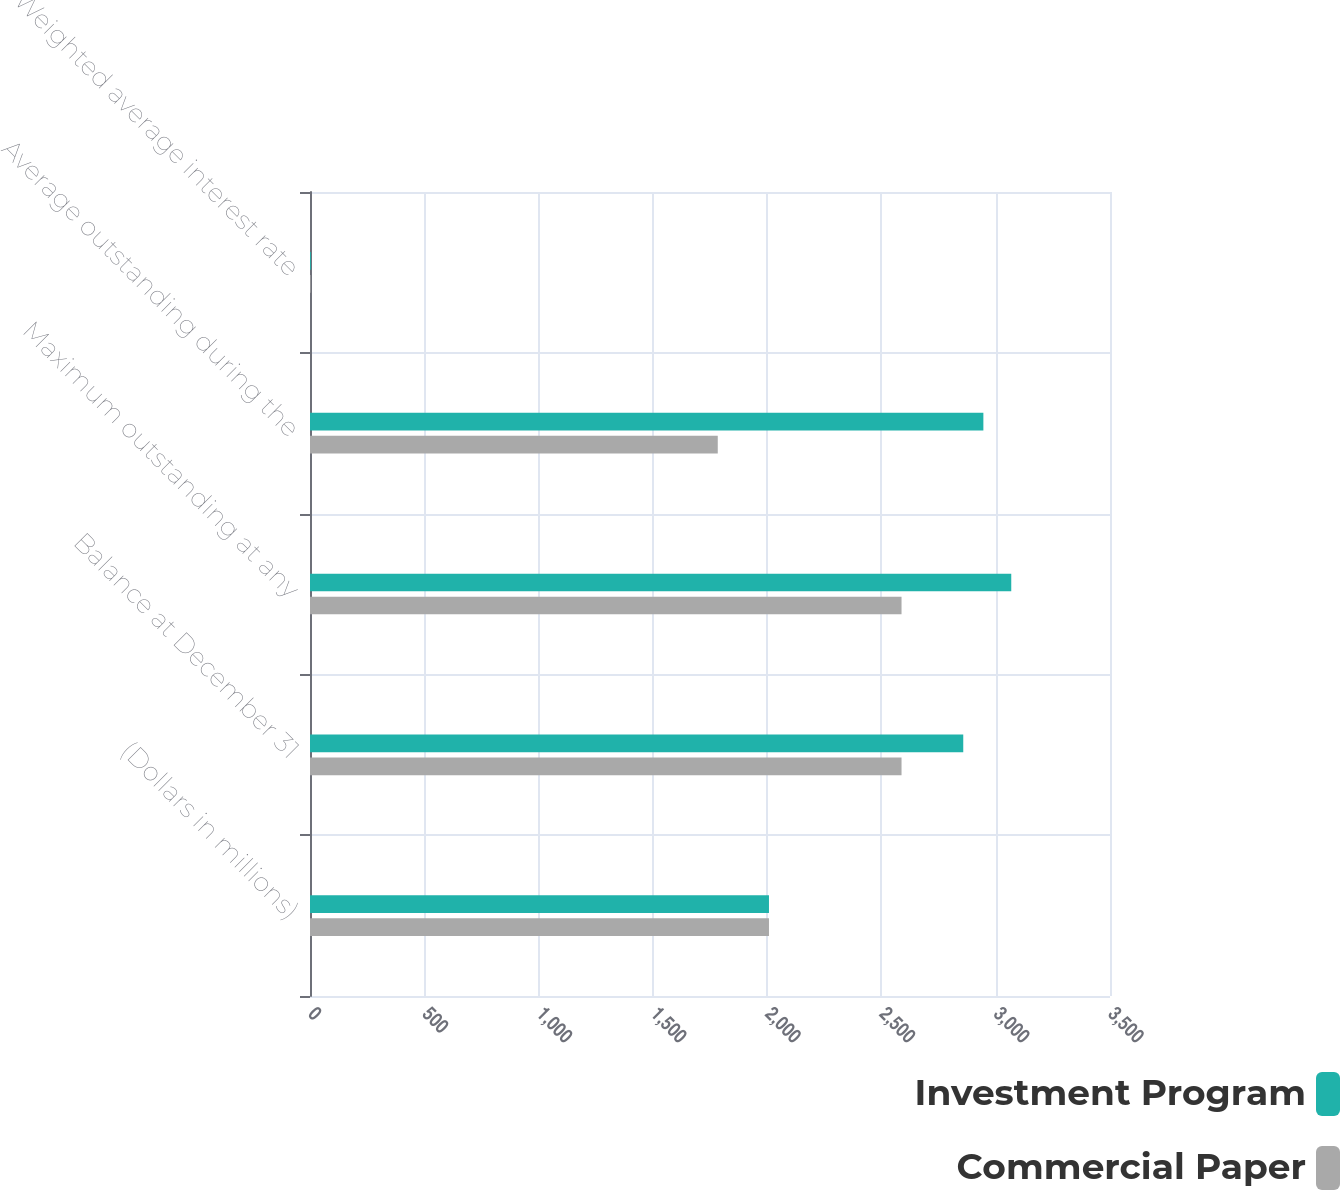<chart> <loc_0><loc_0><loc_500><loc_500><stacked_bar_chart><ecel><fcel>(Dollars in millions)<fcel>Balance at December 31<fcel>Maximum outstanding at any<fcel>Average outstanding during the<fcel>Weighted average interest rate<nl><fcel>Investment Program<fcel>2008<fcel>2858<fcel>3068<fcel>2946<fcel>3.73<nl><fcel>Commercial Paper<fcel>2008<fcel>2588<fcel>2588<fcel>1784<fcel>2.78<nl></chart> 